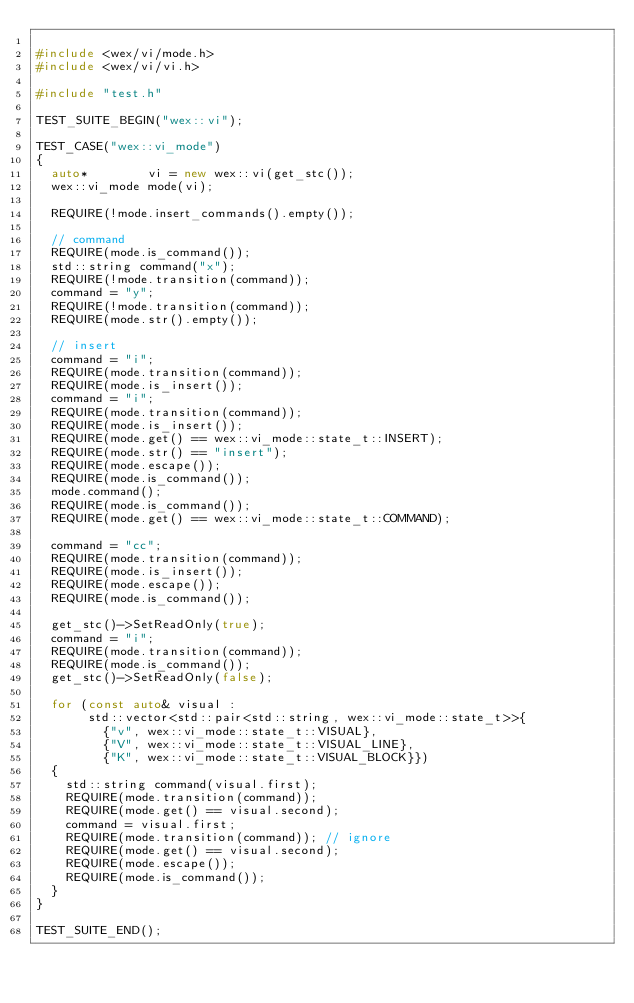Convert code to text. <code><loc_0><loc_0><loc_500><loc_500><_C++_>
#include <wex/vi/mode.h>
#include <wex/vi/vi.h>

#include "test.h"

TEST_SUITE_BEGIN("wex::vi");

TEST_CASE("wex::vi_mode")
{
  auto*        vi = new wex::vi(get_stc());
  wex::vi_mode mode(vi);

  REQUIRE(!mode.insert_commands().empty());

  // command
  REQUIRE(mode.is_command());
  std::string command("x");
  REQUIRE(!mode.transition(command));
  command = "y";
  REQUIRE(!mode.transition(command));
  REQUIRE(mode.str().empty());

  // insert
  command = "i";
  REQUIRE(mode.transition(command));
  REQUIRE(mode.is_insert());
  command = "i";
  REQUIRE(mode.transition(command));
  REQUIRE(mode.is_insert());
  REQUIRE(mode.get() == wex::vi_mode::state_t::INSERT);
  REQUIRE(mode.str() == "insert");
  REQUIRE(mode.escape());
  REQUIRE(mode.is_command());
  mode.command();
  REQUIRE(mode.is_command());
  REQUIRE(mode.get() == wex::vi_mode::state_t::COMMAND);

  command = "cc";
  REQUIRE(mode.transition(command));
  REQUIRE(mode.is_insert());
  REQUIRE(mode.escape());
  REQUIRE(mode.is_command());

  get_stc()->SetReadOnly(true);
  command = "i";
  REQUIRE(mode.transition(command));
  REQUIRE(mode.is_command());
  get_stc()->SetReadOnly(false);

  for (const auto& visual :
       std::vector<std::pair<std::string, wex::vi_mode::state_t>>{
         {"v", wex::vi_mode::state_t::VISUAL},
         {"V", wex::vi_mode::state_t::VISUAL_LINE},
         {"K", wex::vi_mode::state_t::VISUAL_BLOCK}})
  {
    std::string command(visual.first);
    REQUIRE(mode.transition(command));
    REQUIRE(mode.get() == visual.second);
    command = visual.first;
    REQUIRE(mode.transition(command)); // ignore
    REQUIRE(mode.get() == visual.second);
    REQUIRE(mode.escape());
    REQUIRE(mode.is_command());
  }
}

TEST_SUITE_END();
</code> 